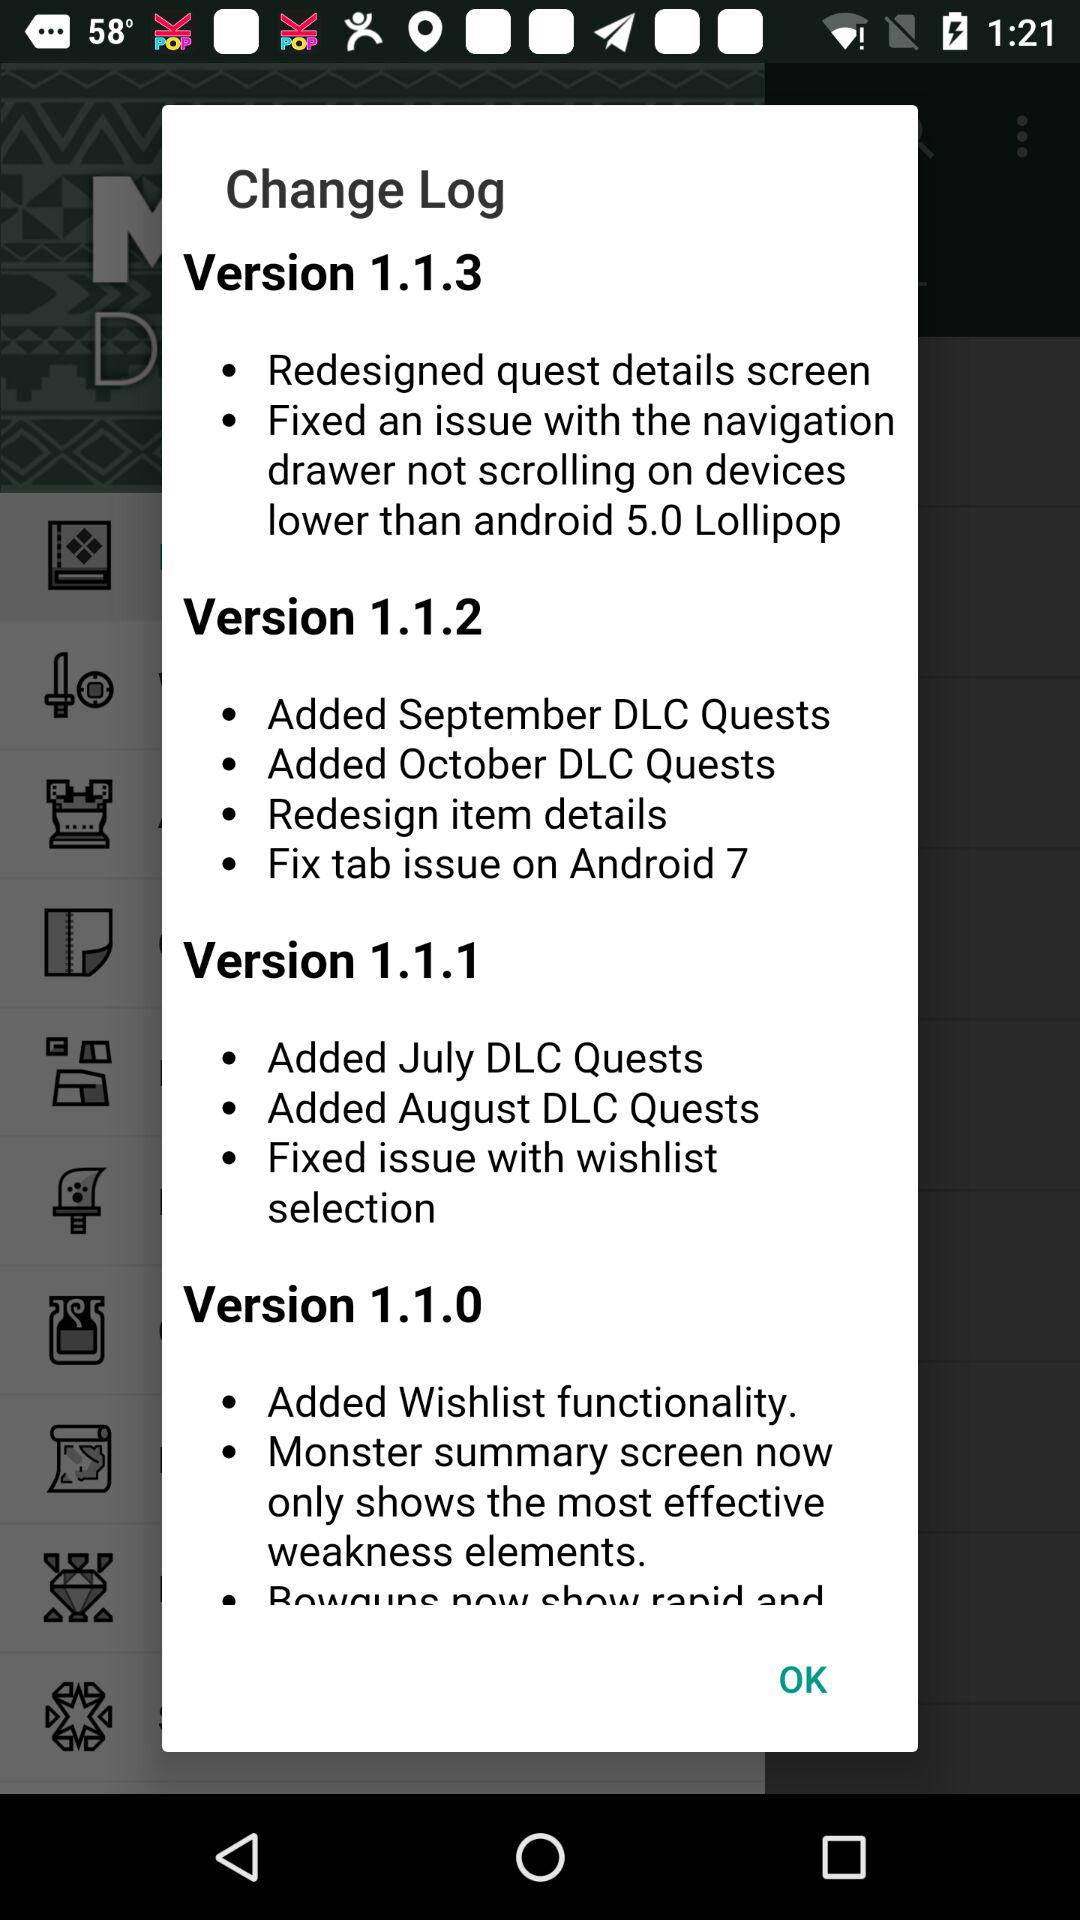What are the features of version 1.1.1? The features are "Added July DLC Quests", "Added August DLC Quests" and "Fixed issue with wishlist selection". 